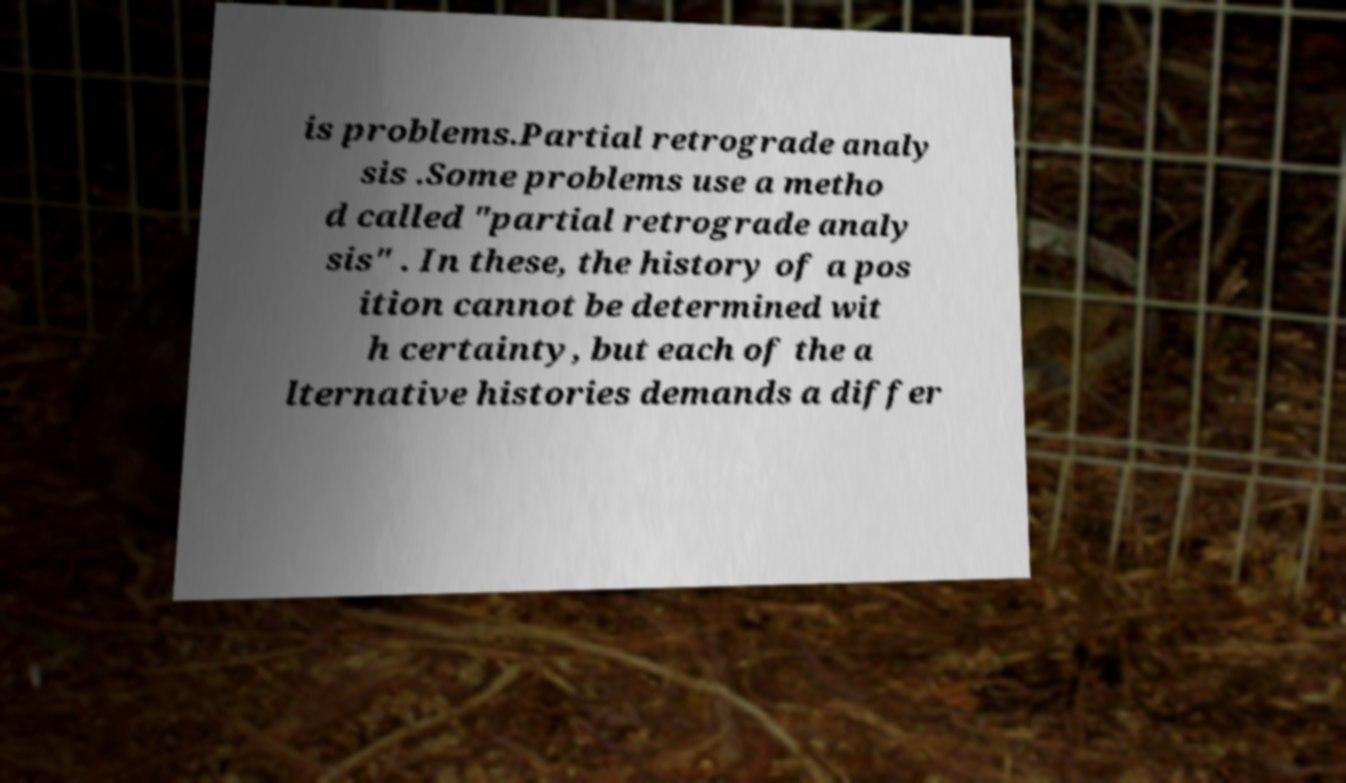What messages or text are displayed in this image? I need them in a readable, typed format. is problems.Partial retrograde analy sis .Some problems use a metho d called "partial retrograde analy sis" . In these, the history of a pos ition cannot be determined wit h certainty, but each of the a lternative histories demands a differ 